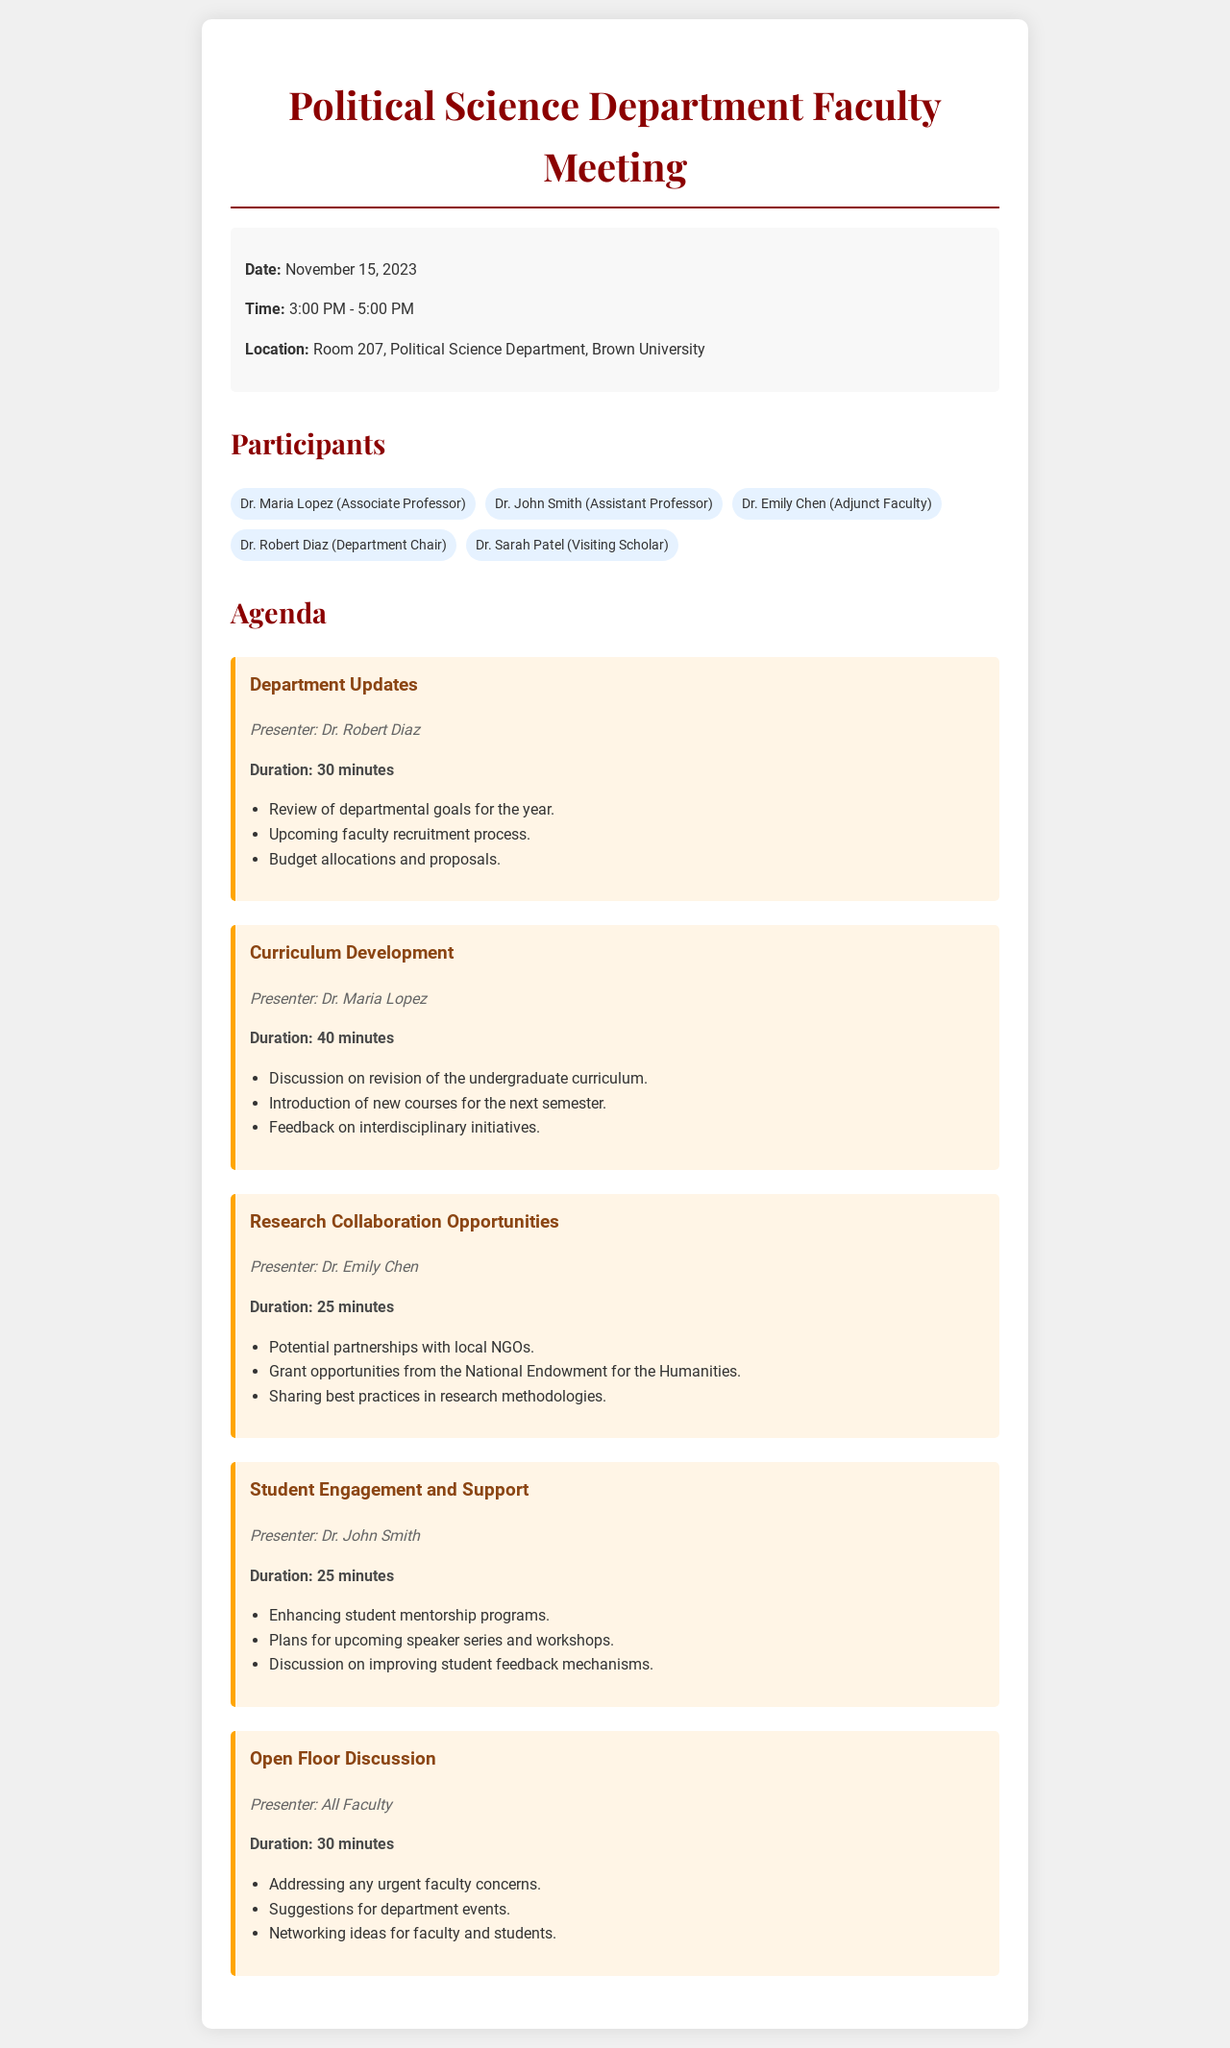What is the date of the meeting? The date of the meeting is specified in the document's meeting information section.
Answer: November 15, 2023 Who is the presenter for "Department Updates"? The presenter's name is mentioned directly beneath the agenda item title for "Department Updates."
Answer: Dr. Robert Diaz How long is the "Curriculum Development" discussion? The duration is listed under the presenter section of the "Curriculum Development" agenda item.
Answer: 40 minutes What are the names of the participants in the meeting? A list of participants is provided in the participants section of the document.
Answer: Dr. Maria Lopez, Dr. John Smith, Dr. Emily Chen, Dr. Robert Diaz, Dr. Sarah Patel Which agenda item has the longest duration? The duration for each agenda item is mentioned, and the longest can be inferred by comparing them.
Answer: Curriculum Development What is the location of the meeting? The location is stated in the meeting information section of the document.
Answer: Room 207, Political Science Department, Brown University Who is responsible for discussing "Research Collaboration Opportunities"? The presenter for each agenda item is indicated clearly in the document.
Answer: Dr. Emily Chen What is the main topic of the "Open Floor Discussion"? The main topic can be found in the agenda item description outlined for the "Open Floor Discussion."
Answer: Addressing any urgent faculty concerns How many total agenda items are listed? The total number of agenda items can be counted from the agenda section of the document.
Answer: 5 